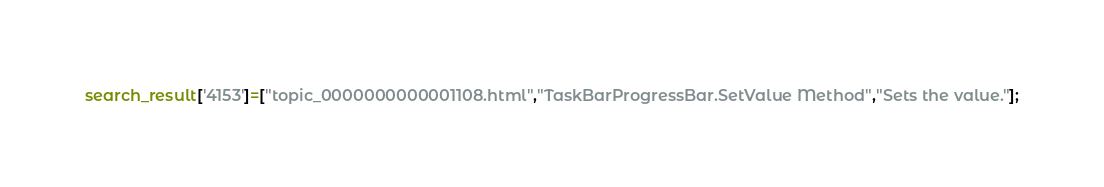Convert code to text. <code><loc_0><loc_0><loc_500><loc_500><_JavaScript_>search_result['4153']=["topic_0000000000001108.html","TaskBarProgressBar.SetValue Method","Sets the value."];</code> 